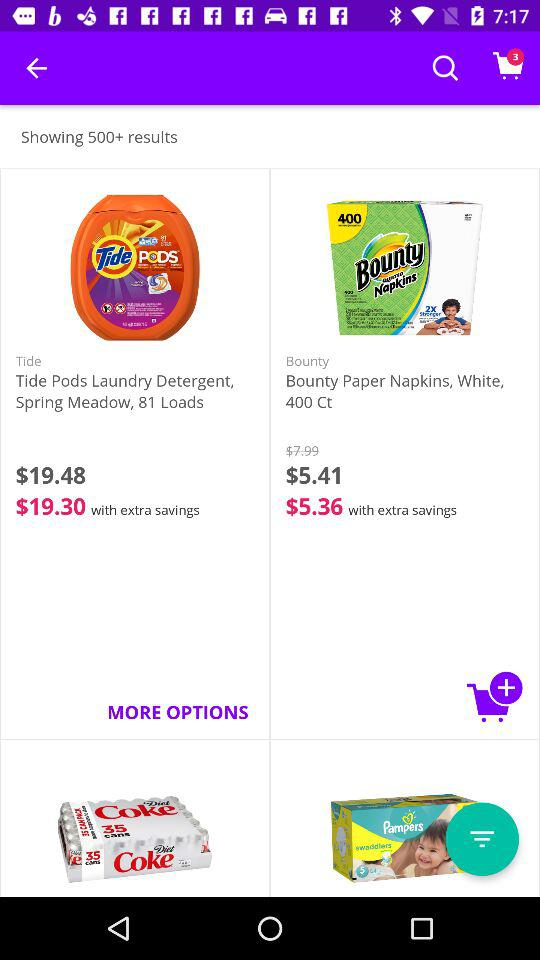How many results are shown? There are more than 500 results. 